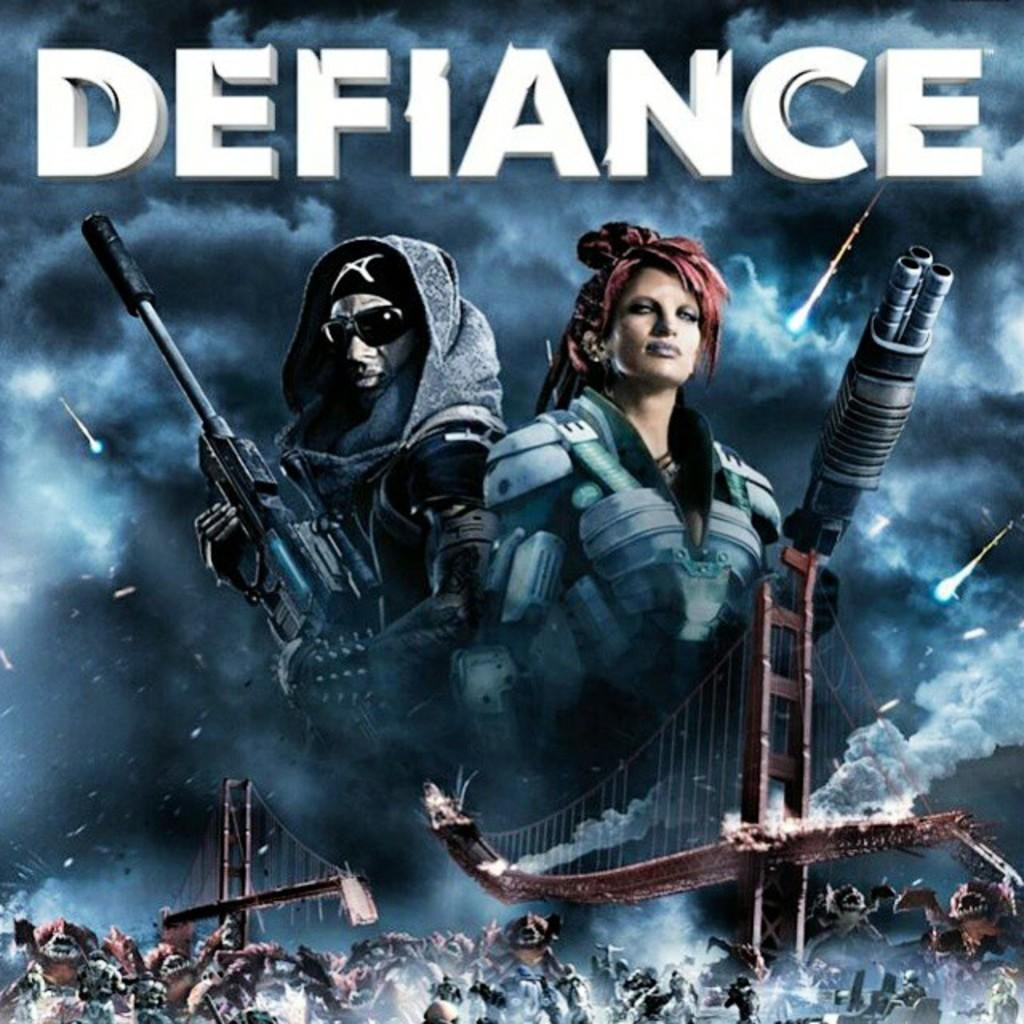<image>
Give a short and clear explanation of the subsequent image. The cover for the video game titled defiance with a ruined san francisco bridge. 